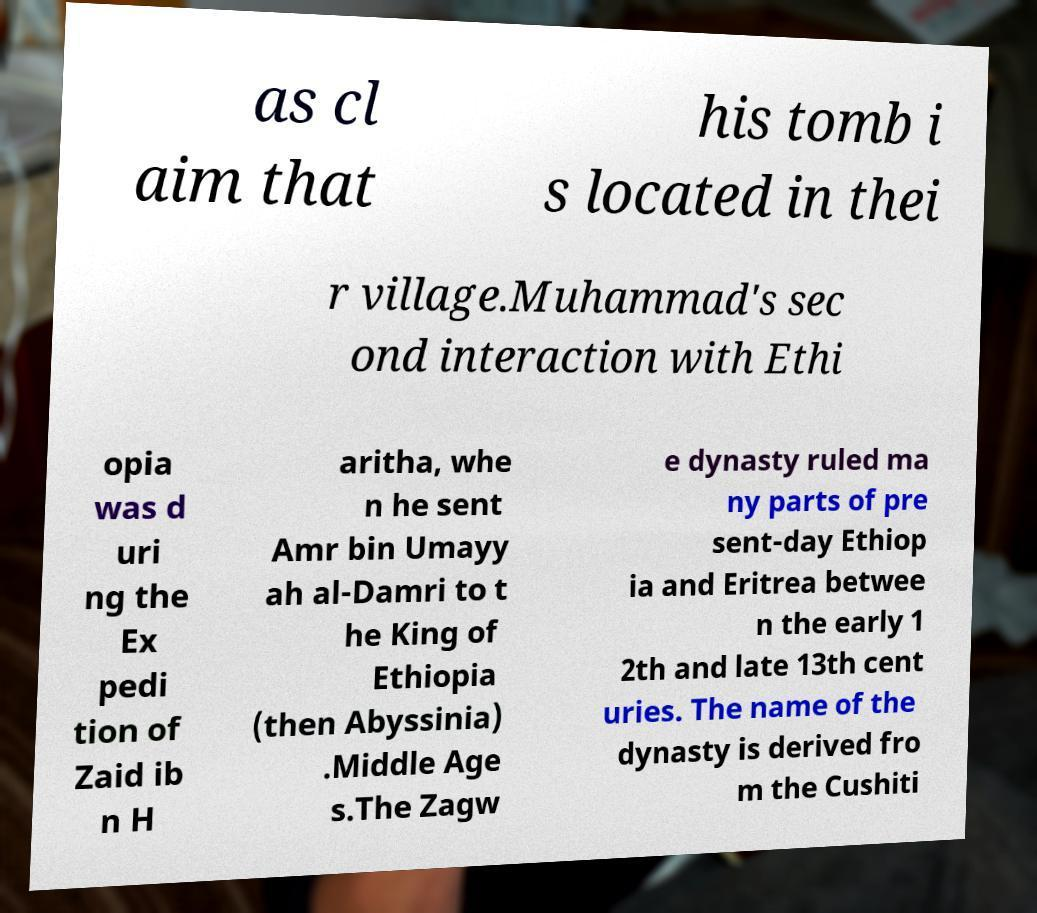Please identify and transcribe the text found in this image. as cl aim that his tomb i s located in thei r village.Muhammad's sec ond interaction with Ethi opia was d uri ng the Ex pedi tion of Zaid ib n H aritha, whe n he sent Amr bin Umayy ah al-Damri to t he King of Ethiopia (then Abyssinia) .Middle Age s.The Zagw e dynasty ruled ma ny parts of pre sent-day Ethiop ia and Eritrea betwee n the early 1 2th and late 13th cent uries. The name of the dynasty is derived fro m the Cushiti 